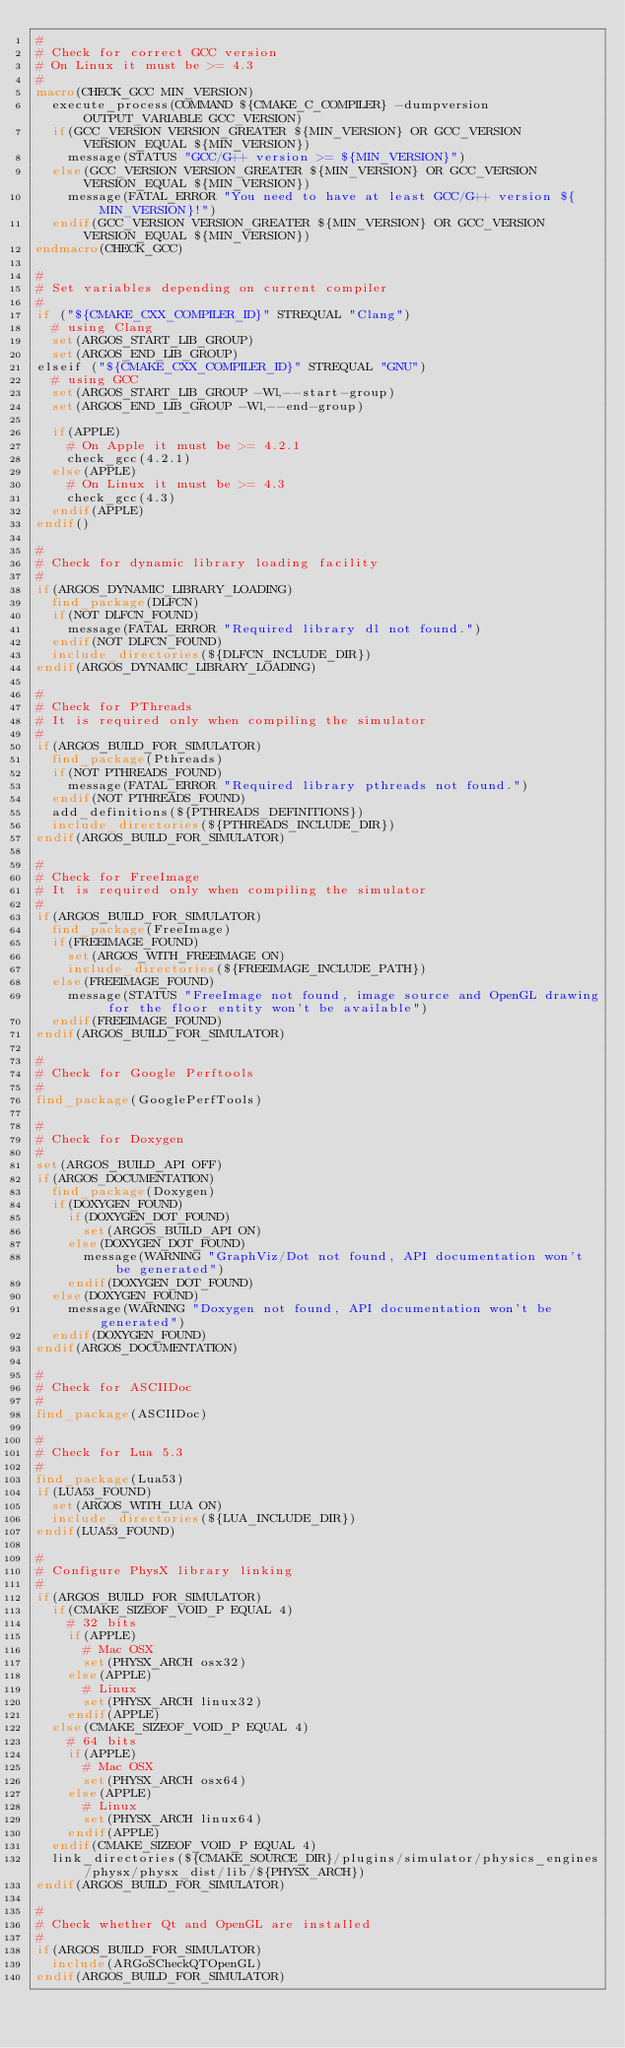<code> <loc_0><loc_0><loc_500><loc_500><_CMake_>#
# Check for correct GCC version
# On Linux it must be >= 4.3
#
macro(CHECK_GCC MIN_VERSION)
  execute_process(COMMAND ${CMAKE_C_COMPILER} -dumpversion OUTPUT_VARIABLE GCC_VERSION)
  if(GCC_VERSION VERSION_GREATER ${MIN_VERSION} OR GCC_VERSION VERSION_EQUAL ${MIN_VERSION})
    message(STATUS "GCC/G++ version >= ${MIN_VERSION}")
  else(GCC_VERSION VERSION_GREATER ${MIN_VERSION} OR GCC_VERSION VERSION_EQUAL ${MIN_VERSION})
    message(FATAL_ERROR "You need to have at least GCC/G++ version ${MIN_VERSION}!")
  endif(GCC_VERSION VERSION_GREATER ${MIN_VERSION} OR GCC_VERSION VERSION_EQUAL ${MIN_VERSION})
endmacro(CHECK_GCC)

#
# Set variables depending on current compiler
#
if ("${CMAKE_CXX_COMPILER_ID}" STREQUAL "Clang")
  # using Clang
  set(ARGOS_START_LIB_GROUP)
  set(ARGOS_END_LIB_GROUP)
elseif ("${CMAKE_CXX_COMPILER_ID}" STREQUAL "GNU")
  # using GCC
  set(ARGOS_START_LIB_GROUP -Wl,--start-group)
  set(ARGOS_END_LIB_GROUP -Wl,--end-group)

  if(APPLE)
    # On Apple it must be >= 4.2.1
    check_gcc(4.2.1)
  else(APPLE)
    # On Linux it must be >= 4.3
    check_gcc(4.3)
  endif(APPLE)
endif()

#
# Check for dynamic library loading facility
#
if(ARGOS_DYNAMIC_LIBRARY_LOADING)
  find_package(DLFCN)
  if(NOT DLFCN_FOUND)
    message(FATAL_ERROR "Required library dl not found.")
  endif(NOT DLFCN_FOUND)
  include_directories(${DLFCN_INCLUDE_DIR})
endif(ARGOS_DYNAMIC_LIBRARY_LOADING)

#
# Check for PThreads
# It is required only when compiling the simulator
#
if(ARGOS_BUILD_FOR_SIMULATOR)
  find_package(Pthreads)
  if(NOT PTHREADS_FOUND)
    message(FATAL_ERROR "Required library pthreads not found.")
  endif(NOT PTHREADS_FOUND)
  add_definitions(${PTHREADS_DEFINITIONS})
  include_directories(${PTHREADS_INCLUDE_DIR})
endif(ARGOS_BUILD_FOR_SIMULATOR)

#
# Check for FreeImage
# It is required only when compiling the simulator
#
if(ARGOS_BUILD_FOR_SIMULATOR)
  find_package(FreeImage)
  if(FREEIMAGE_FOUND)
    set(ARGOS_WITH_FREEIMAGE ON)
    include_directories(${FREEIMAGE_INCLUDE_PATH})
  else(FREEIMAGE_FOUND)
    message(STATUS "FreeImage not found, image source and OpenGL drawing for the floor entity won't be available")
  endif(FREEIMAGE_FOUND)
endif(ARGOS_BUILD_FOR_SIMULATOR)

#
# Check for Google Perftools
#
find_package(GooglePerfTools)

#
# Check for Doxygen
#
set(ARGOS_BUILD_API OFF)
if(ARGOS_DOCUMENTATION)
  find_package(Doxygen)
  if(DOXYGEN_FOUND)
    if(DOXYGEN_DOT_FOUND)
      set(ARGOS_BUILD_API ON)
    else(DOXYGEN_DOT_FOUND)
      message(WARNING "GraphViz/Dot not found, API documentation won't be generated")
    endif(DOXYGEN_DOT_FOUND)
  else(DOXYGEN_FOUND)
    message(WARNING "Doxygen not found, API documentation won't be generated")
  endif(DOXYGEN_FOUND)
endif(ARGOS_DOCUMENTATION)

#
# Check for ASCIIDoc
#
find_package(ASCIIDoc)

#
# Check for Lua 5.3
#
find_package(Lua53)
if(LUA53_FOUND)
  set(ARGOS_WITH_LUA ON)
  include_directories(${LUA_INCLUDE_DIR})
endif(LUA53_FOUND)

#
# Configure PhysX library linking
#
if(ARGOS_BUILD_FOR_SIMULATOR)
  if(CMAKE_SIZEOF_VOID_P EQUAL 4)
    # 32 bits
    if(APPLE)
      # Mac OSX
      set(PHYSX_ARCH osx32)
    else(APPLE)
      # Linux
      set(PHYSX_ARCH linux32)
    endif(APPLE)
  else(CMAKE_SIZEOF_VOID_P EQUAL 4)
    # 64 bits
    if(APPLE)
      # Mac OSX
      set(PHYSX_ARCH osx64)
    else(APPLE)
      # Linux
      set(PHYSX_ARCH linux64)
    endif(APPLE)
  endif(CMAKE_SIZEOF_VOID_P EQUAL 4)
  link_directories(${CMAKE_SOURCE_DIR}/plugins/simulator/physics_engines/physx/physx_dist/lib/${PHYSX_ARCH})
endif(ARGOS_BUILD_FOR_SIMULATOR)

#
# Check whether Qt and OpenGL are installed
#
if(ARGOS_BUILD_FOR_SIMULATOR)
  include(ARGoSCheckQTOpenGL)
endif(ARGOS_BUILD_FOR_SIMULATOR)
</code> 